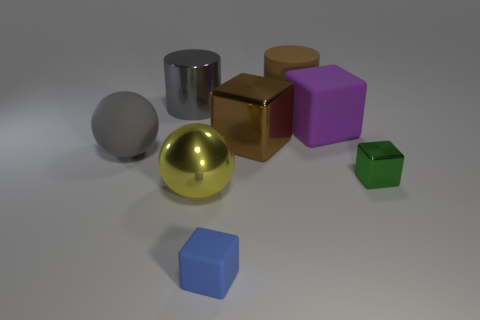Subtract all big purple cubes. How many cubes are left? 3 Subtract 2 cubes. How many cubes are left? 2 Add 2 brown shiny cubes. How many objects exist? 10 Subtract all green cubes. How many cubes are left? 3 Subtract all green balls. How many purple cylinders are left? 0 Subtract all big blue cylinders. Subtract all rubber balls. How many objects are left? 7 Add 5 large brown things. How many large brown things are left? 7 Add 4 brown things. How many brown things exist? 6 Subtract 1 brown cylinders. How many objects are left? 7 Subtract all red spheres. Subtract all green cylinders. How many spheres are left? 2 